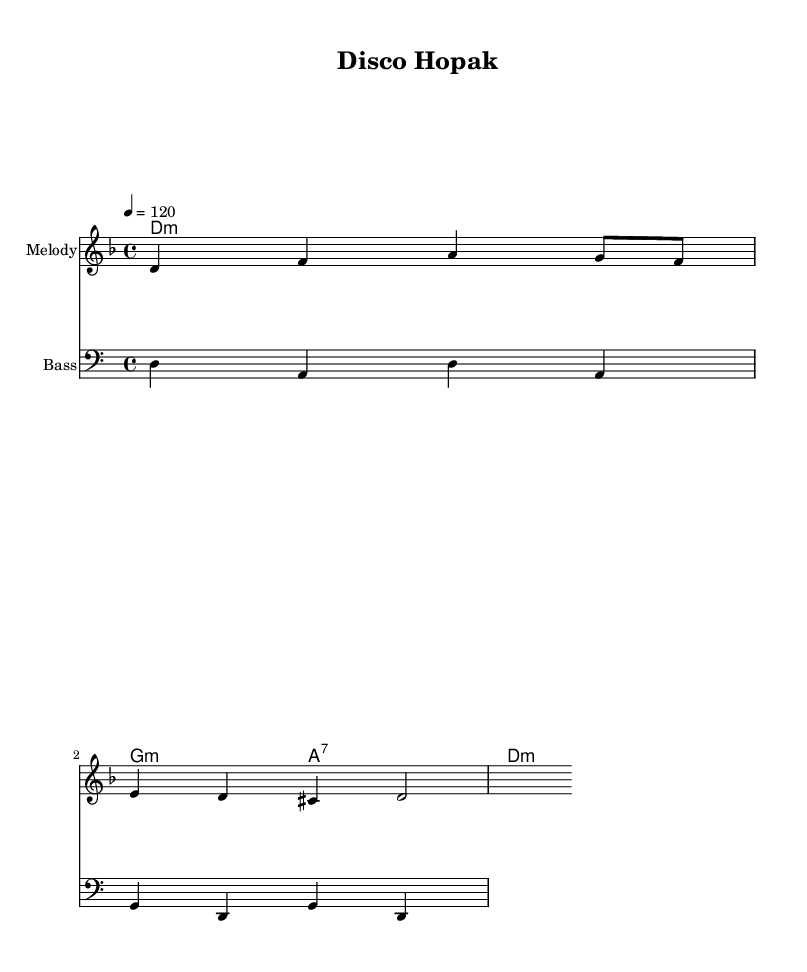What is the key signature of this music? The key signature is identified by the presence of one flat (B flat) in the beginning, which indicates that the piece is in D minor.
Answer: D minor What is the time signature of this piece? The time signature is indicated by the "4/4" at the beginning of the score, specifying that there are four beats per measure and the quarter note gets one beat.
Answer: 4/4 What is the tempo marking given in the score? The tempo is marked "4 = 120," meaning that a quarter note should be played at a speed of 120 beats per minute.
Answer: 120 How many measures are in the melody? By counting the distinct sets of notes and observing the divisions in the notation, the melody consists of four measures in total.
Answer: 4 What type of chord is played in the first measure? The first measure of the harmony section shows a "d:m" chord, which signifies that it is a D minor chord.
Answer: D minor What rhythmic pattern is predominant in the bass line? The bass line follows a repetitive pattern where each note played is a quarter note, creating a steady rhythmic foundation for the piece.
Answer: Quarter notes How does the melody reflect the Disco genre? The melody is structured with a repetitive and catchy line typical of Disco music, emphasizing strong rhythmic elements and vibrant pitches.
Answer: Catchy and rhythmic 